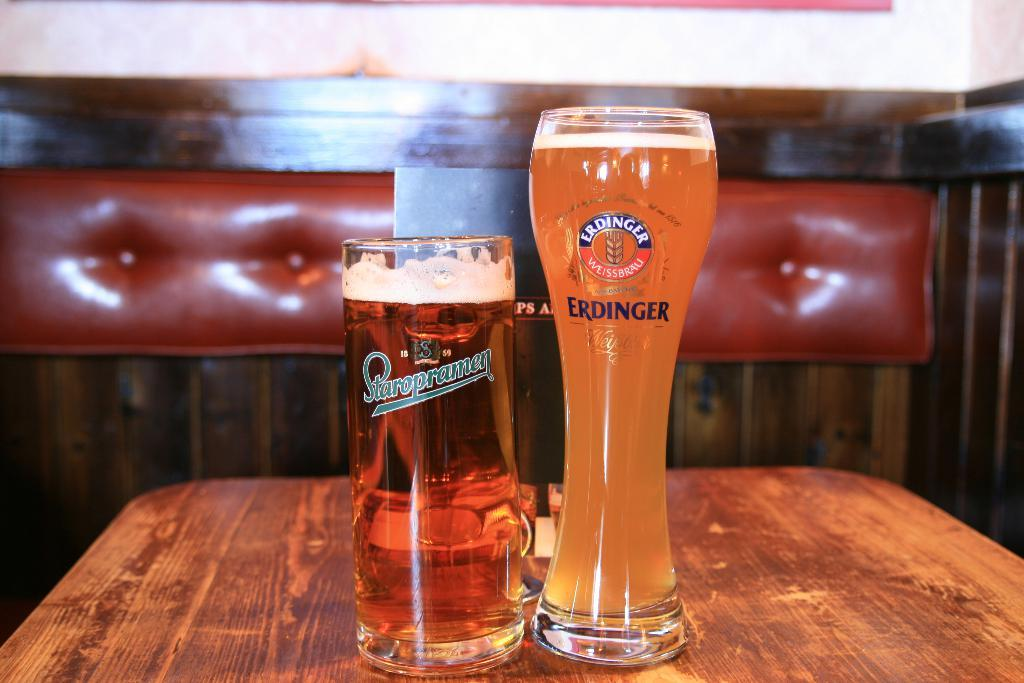<image>
Offer a succinct explanation of the picture presented. Two different size glasses of Staropramend and Erdinger beer sit on a table. 